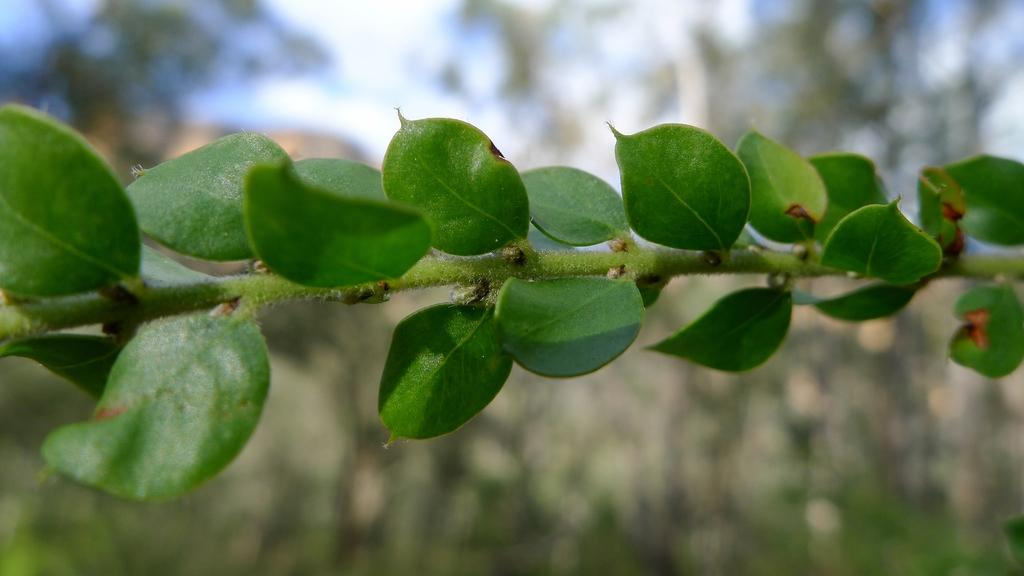What is the main subject of the image? The main subject of the image is a group of leaves. Can you describe the leaves' location in the image? The leaves are on a stem of a plant. Is there a volcano erupting in the background of the image? No, there is no volcano or any indication of an eruption in the image. 